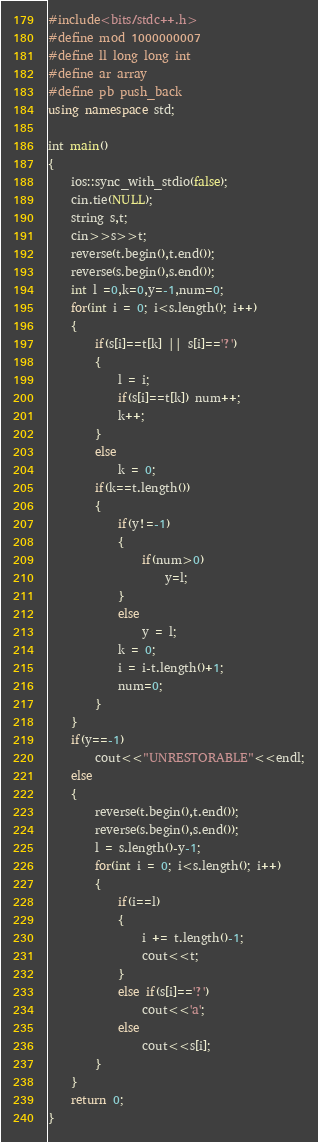<code> <loc_0><loc_0><loc_500><loc_500><_C++_>#include<bits/stdc++.h>
#define mod 1000000007
#define ll long long int
#define ar array
#define pb push_back
using namespace std;

int main()
{
	ios::sync_with_stdio(false);
	cin.tie(NULL);
	string s,t;
	cin>>s>>t;
	reverse(t.begin(),t.end());
	reverse(s.begin(),s.end());
	int l =0,k=0,y=-1,num=0;
	for(int i = 0; i<s.length(); i++)
	{
		if(s[i]==t[k] || s[i]=='?')
		{
			l = i;
			if(s[i]==t[k]) num++;
			k++;
		}
		else
			k = 0;
		if(k==t.length())
		{
			if(y!=-1)
			{
				if(num>0)
					y=l;
			}
			else
				y = l;
			k = 0;
			i = i-t.length()+1;
			num=0;
		}
	}
	if(y==-1)
		cout<<"UNRESTORABLE"<<endl;
	else
	{
		reverse(t.begin(),t.end());
		reverse(s.begin(),s.end());
		l = s.length()-y-1;
		for(int i = 0; i<s.length(); i++)
		{
			if(i==l)
			{
				i += t.length()-1;
				cout<<t;
			}
			else if(s[i]=='?')
				cout<<'a';
			else
				cout<<s[i];
		}
	}
	return 0;
}</code> 